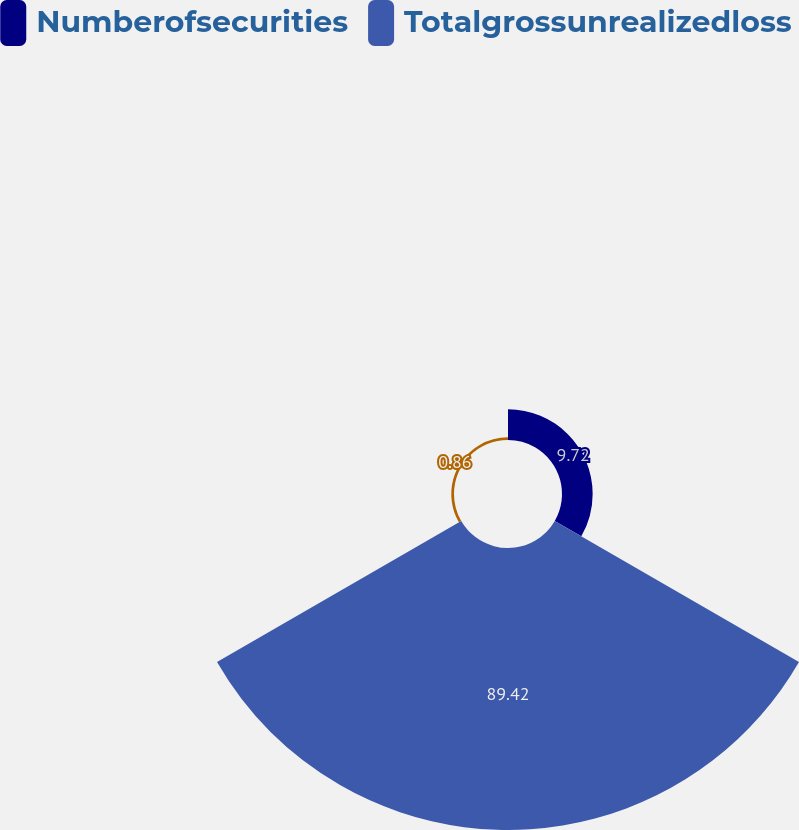<chart> <loc_0><loc_0><loc_500><loc_500><pie_chart><fcel>Numberofsecurities<fcel>Totalgrossunrealizedloss<fcel>Unnamed: 2<nl><fcel>9.72%<fcel>89.42%<fcel>0.86%<nl></chart> 